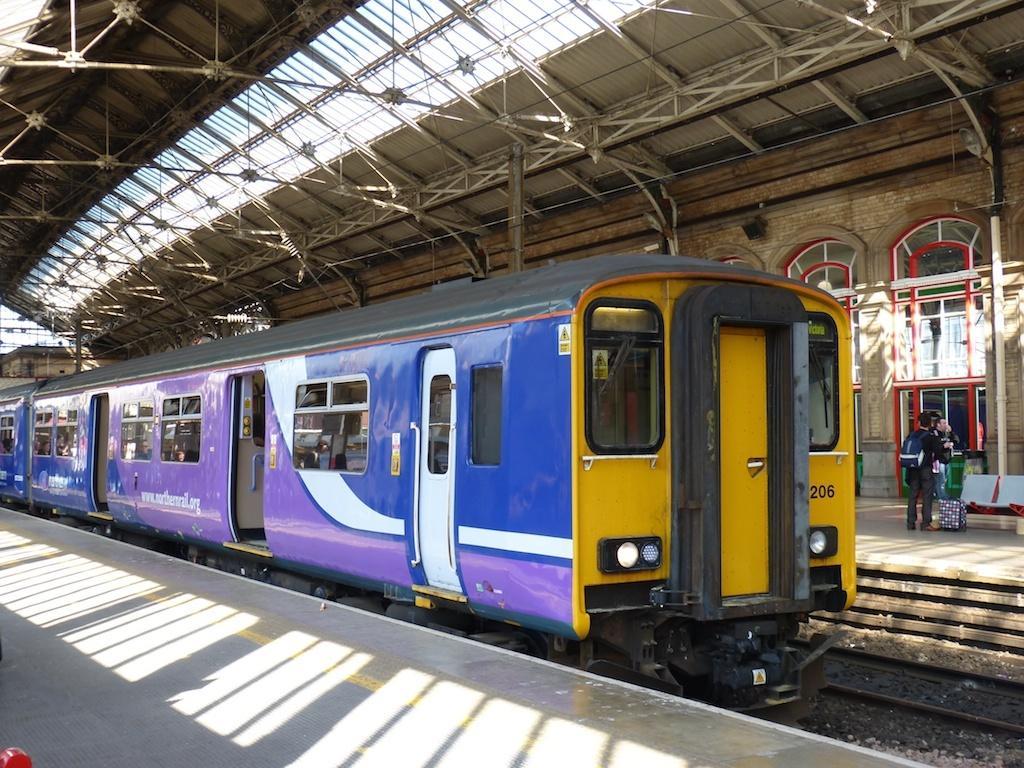Could you give a brief overview of what you see in this image? This picture is taken inside the railway station. In this image, in the middle, we can see a train which is in blue and yellow color is moving on the railway track. On the right side, we can see a group of people wearing a backpack is standing on the land and on the right side, we can see a glass window. At the top, we can see a roof, at the bottom, we can see a land and a railway track with some stones. 